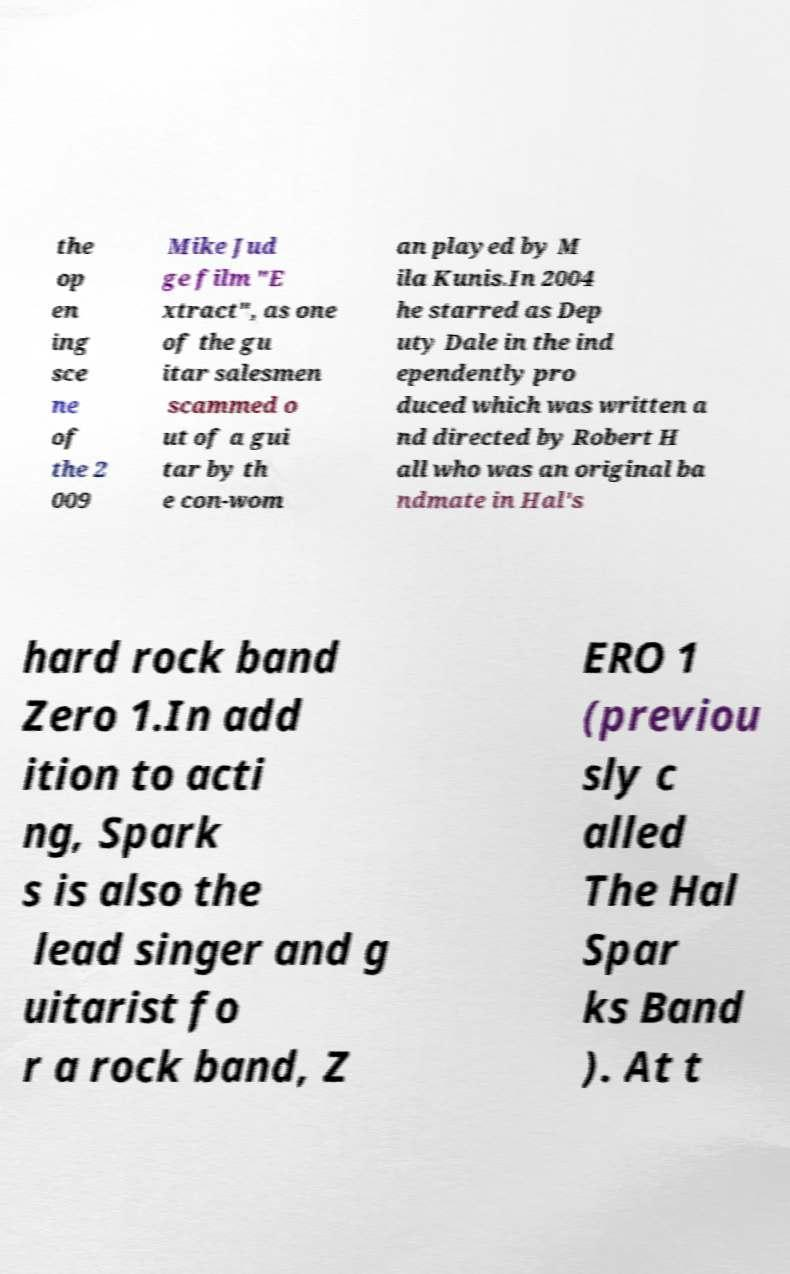What messages or text are displayed in this image? I need them in a readable, typed format. the op en ing sce ne of the 2 009 Mike Jud ge film "E xtract", as one of the gu itar salesmen scammed o ut of a gui tar by th e con-wom an played by M ila Kunis.In 2004 he starred as Dep uty Dale in the ind ependently pro duced which was written a nd directed by Robert H all who was an original ba ndmate in Hal's hard rock band Zero 1.In add ition to acti ng, Spark s is also the lead singer and g uitarist fo r a rock band, Z ERO 1 (previou sly c alled The Hal Spar ks Band ). At t 